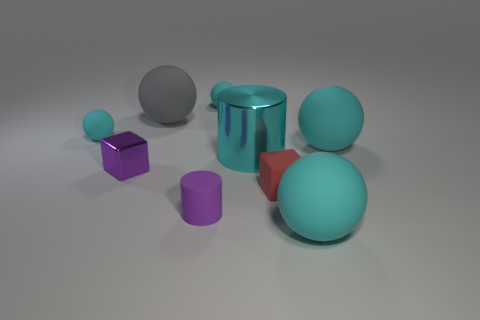How many cyan spheres must be subtracted to get 1 cyan spheres? 3 Subtract all tiny cyan rubber spheres. How many spheres are left? 3 Subtract all gray blocks. How many cyan balls are left? 4 Subtract all gray spheres. How many spheres are left? 4 Add 1 red rubber objects. How many objects exist? 10 Subtract all cyan objects. Subtract all big cylinders. How many objects are left? 3 Add 4 gray matte objects. How many gray matte objects are left? 5 Add 3 purple rubber cylinders. How many purple rubber cylinders exist? 4 Subtract 0 gray cylinders. How many objects are left? 9 Subtract all spheres. How many objects are left? 4 